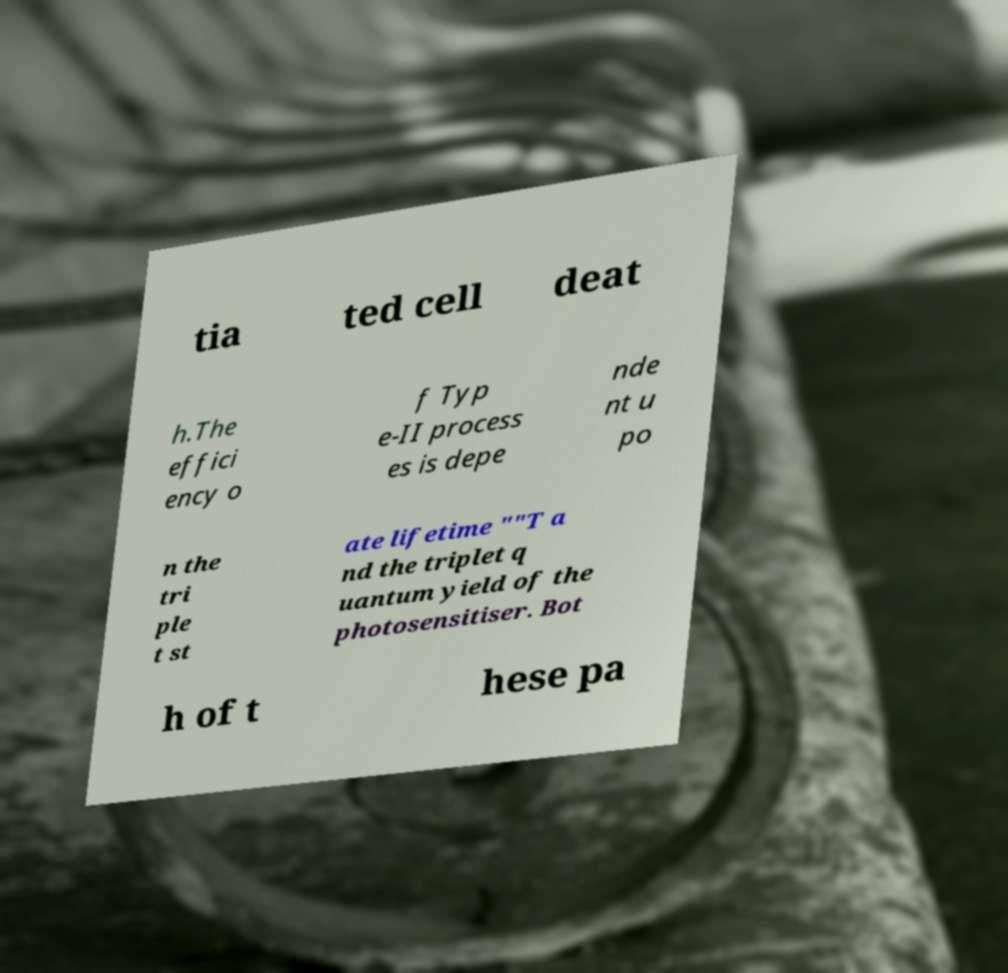For documentation purposes, I need the text within this image transcribed. Could you provide that? tia ted cell deat h.The effici ency o f Typ e-II process es is depe nde nt u po n the tri ple t st ate lifetime ""T a nd the triplet q uantum yield of the photosensitiser. Bot h of t hese pa 